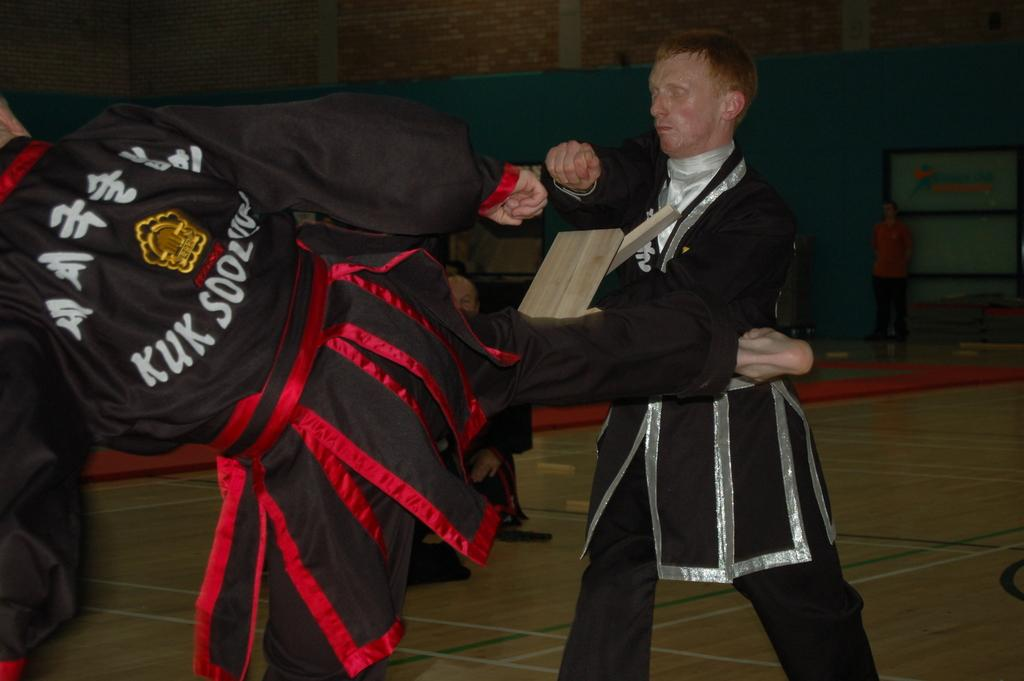<image>
Present a compact description of the photo's key features. One man wearing a Kuk Sool jackets kicks and breaks a board that another man is holding in this Asian style fighting. 